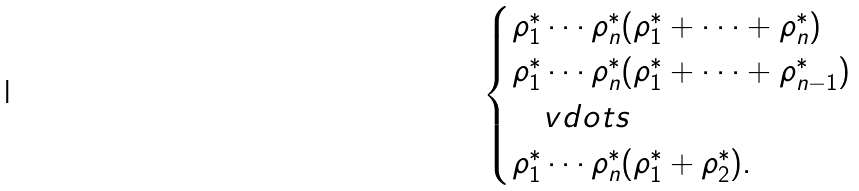<formula> <loc_0><loc_0><loc_500><loc_500>\begin{cases} \rho _ { 1 } ^ { * } \cdots \rho _ { n } ^ { * } ( \rho _ { 1 } ^ { * } + \cdots + \rho _ { n } ^ { * } ) \\ \rho _ { 1 } ^ { * } \cdots \rho _ { n } ^ { * } ( \rho _ { 1 } ^ { * } + \cdots + \rho _ { n - 1 } ^ { * } ) \\ \quad v d o t s \\ \rho _ { 1 } ^ { * } \cdots \rho _ { n } ^ { * } ( \rho _ { 1 } ^ { * } + \rho _ { 2 } ^ { * } ) . \end{cases}</formula> 